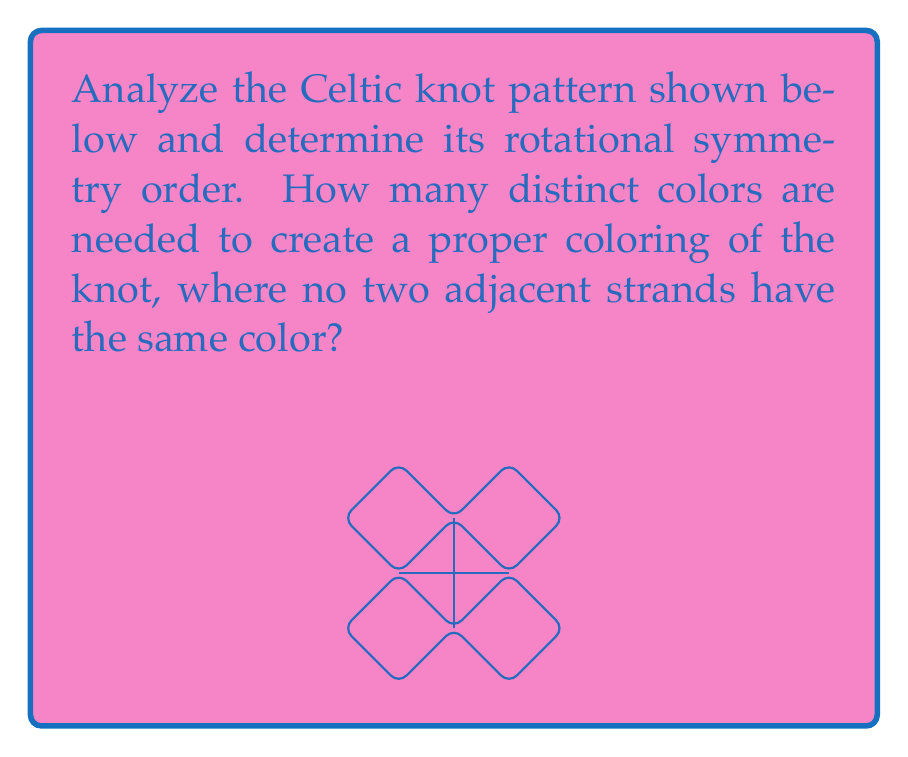Can you answer this question? To solve this problem, we need to analyze the symmetry and structure of the given Celtic knot:

1. Rotational symmetry:
   - Observe that the knot has 90-degree rotational symmetry.
   - A full 360-degree rotation brings the knot back to its original position 4 times.
   - Therefore, the rotational symmetry order is 4.

2. Proper coloring:
   - In a proper coloring, no two adjacent strands should have the same color.
   - Trace the knot and label each strand:
     a. Start with one strand and label it color 1.
     b. Move to an adjacent strand and label it color 2.
     c. Continue this process, using new colors when necessary.

   - We find that we need at least 3 colors to properly color the knot:
     - Color 1: top-left to bottom-right diagonal
     - Color 2: top-right to bottom-left diagonal
     - Color 3: horizontal and vertical strands

   - Attempting to use only 2 colors would result in adjacent strands having the same color.

Therefore, the rotational symmetry order is 4, and the minimum number of colors needed for a proper coloring is 3.
Answer: Rotational symmetry order: 4; Minimum colors needed: 3 